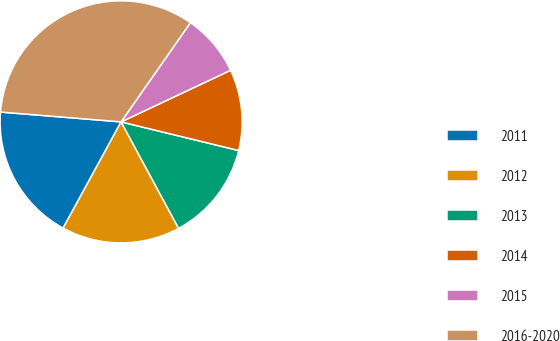<chart> <loc_0><loc_0><loc_500><loc_500><pie_chart><fcel>2011<fcel>2012<fcel>2013<fcel>2014<fcel>2015<fcel>2016-2020<nl><fcel>18.34%<fcel>15.83%<fcel>13.32%<fcel>10.81%<fcel>8.29%<fcel>33.41%<nl></chart> 